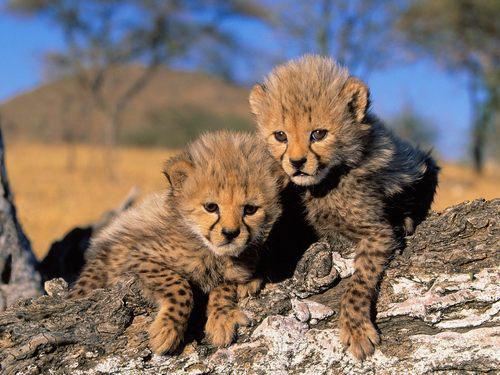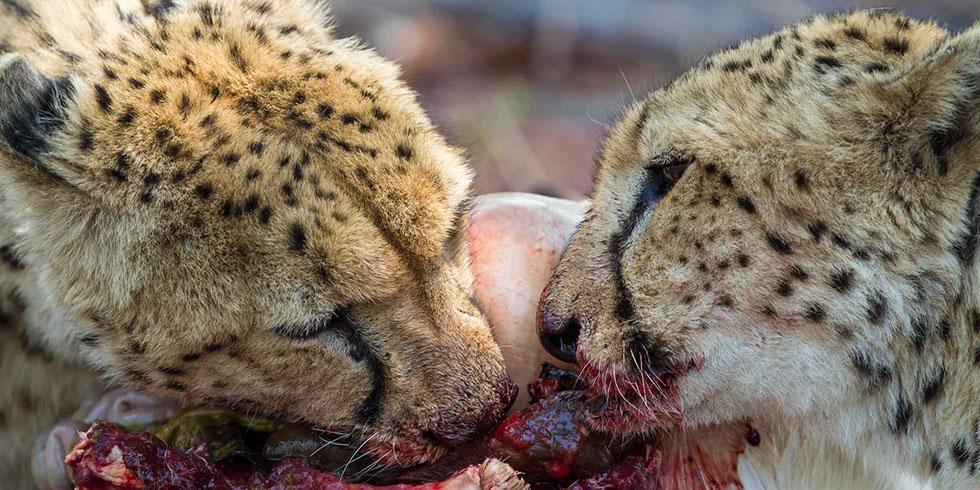The first image is the image on the left, the second image is the image on the right. Examine the images to the left and right. Is the description "At least one cheetah has blood around its mouth." accurate? Answer yes or no. Yes. The first image is the image on the left, the second image is the image on the right. Analyze the images presented: Is the assertion "The left image includes at least one cheetah in a reclining pose with both its front paws forward, and the right image includes a cheetah with a blood-drenched muzzle." valid? Answer yes or no. Yes. 